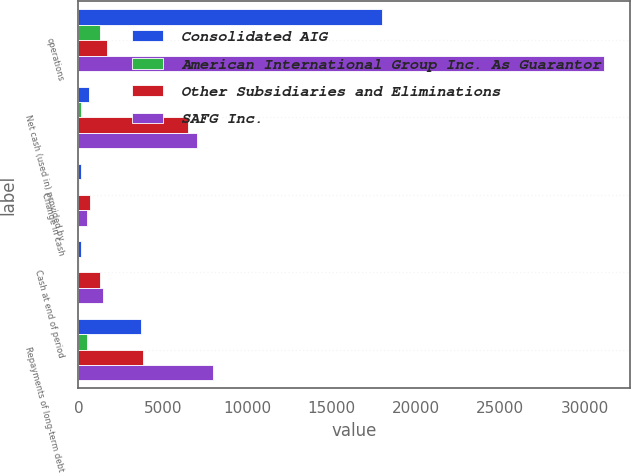Convert chart to OTSL. <chart><loc_0><loc_0><loc_500><loc_500><stacked_bar_chart><ecel><fcel>operations<fcel>Net cash (used in) provided by<fcel>Change in cash<fcel>Cash at end of period<fcel>Repayments of long-term debt<nl><fcel>Consolidated AIG<fcel>17964<fcel>641<fcel>127<fcel>176<fcel>3681<nl><fcel>American International Group Inc. As Guarantor<fcel>1262<fcel>139<fcel>13<fcel>13<fcel>500<nl><fcel>Other Subsidiaries and Eliminations<fcel>1708<fcel>6515<fcel>670<fcel>1285<fcel>3805<nl><fcel>SAFG Inc.<fcel>31130<fcel>7017<fcel>530<fcel>1474<fcel>7986<nl></chart> 